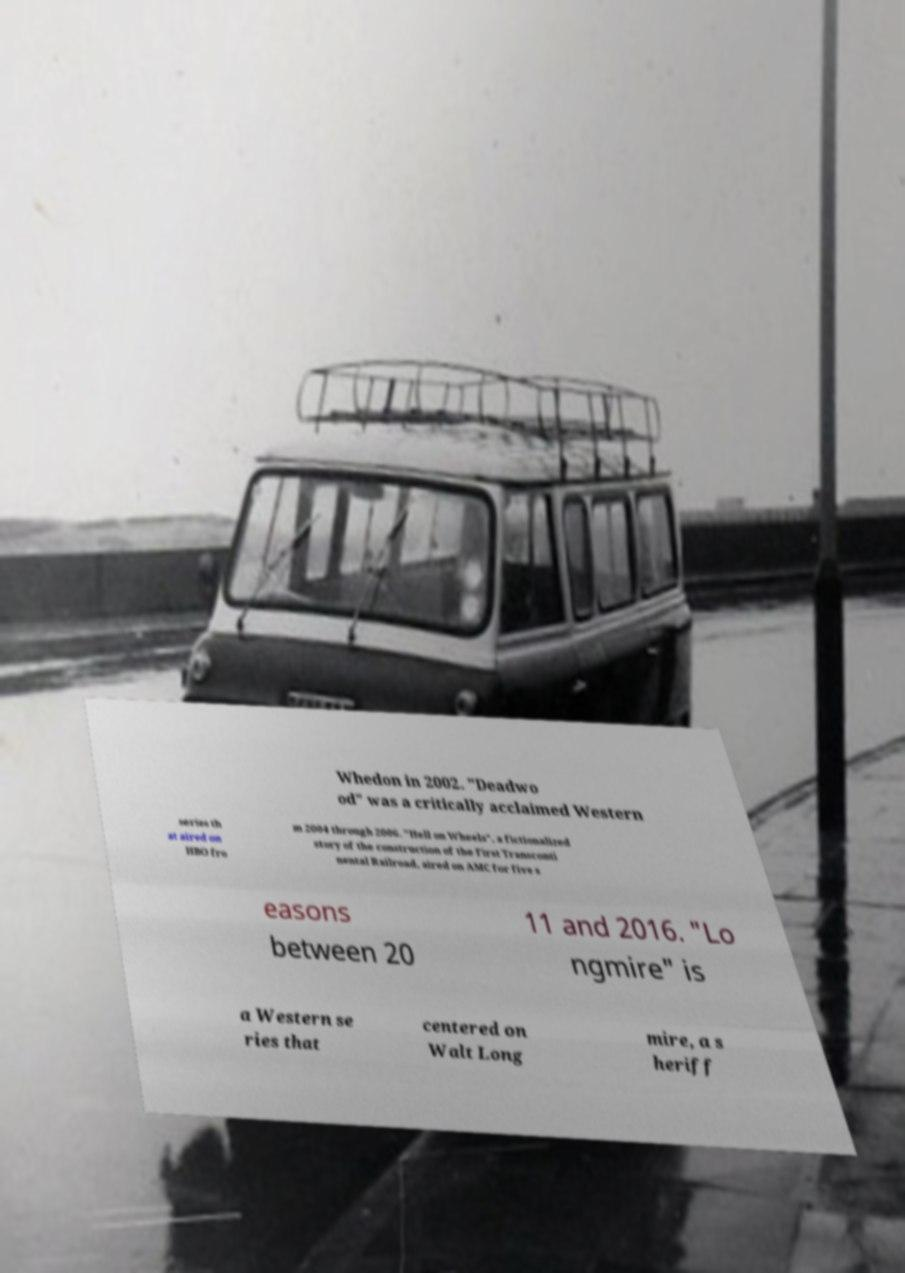Could you extract and type out the text from this image? Whedon in 2002. "Deadwo od" was a critically acclaimed Western series th at aired on HBO fro m 2004 through 2006. "Hell on Wheels", a fictionalized story of the construction of the First Transconti nental Railroad, aired on AMC for five s easons between 20 11 and 2016. "Lo ngmire" is a Western se ries that centered on Walt Long mire, a s heriff 